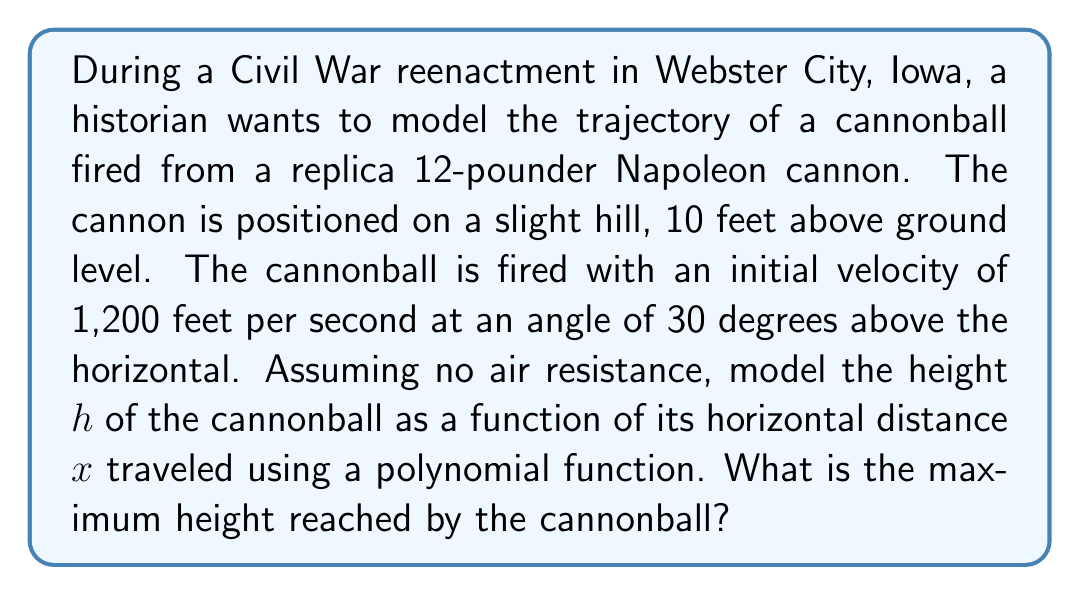Show me your answer to this math problem. Let's approach this step-by-step:

1) The general equation for a projectile motion trajectory is:

   $$h(x) = -\frac{gx^2}{2v_0^2\cos^2\theta} + x\tan\theta + h_0$$

   Where:
   $g$ is the acceleration due to gravity (32 ft/s²)
   $v_0$ is the initial velocity (1,200 ft/s)
   $\theta$ is the launch angle (30°)
   $h_0$ is the initial height (10 ft)

2) Let's substitute these values:

   $$h(x) = -\frac{32x^2}{2(1200^2)\cos^2(30°)} + x\tan(30°) + 10$$

3) Simplify:
   $\cos(30°) = \frac{\sqrt{3}}{2}$, $\tan(30°) = \frac{1}{\sqrt{3}}$

   $$h(x) = -\frac{32x^2}{2(1,440,000)(\frac{3}{4})} + \frac{x}{\sqrt{3}} + 10$$

4) Further simplification:

   $$h(x) = -\frac{x^2}{135,000} + \frac{x}{\sqrt{3}} + 10$$

5) To find the maximum height, we need to find the vertex of this parabola. The x-coordinate of the vertex is given by $x = -\frac{b}{2a}$ where $a$ and $b$ are the coefficients of $x^2$ and $x$ respectively.

   $$x = -\frac{\frac{1}{\sqrt{3}}}{2(-\frac{1}{135,000})} = 116,882.4 \text{ ft}$$

6) To find the maximum height, substitute this x-value back into the equation:

   $$h_{max} = -\frac{(116,882.4)^2}{135,000} + \frac{116,882.4}{\sqrt{3}} + 10$$

7) Calculating this gives:

   $$h_{max} ≈ 33,754 \text{ ft}$$
Answer: 33,754 feet 